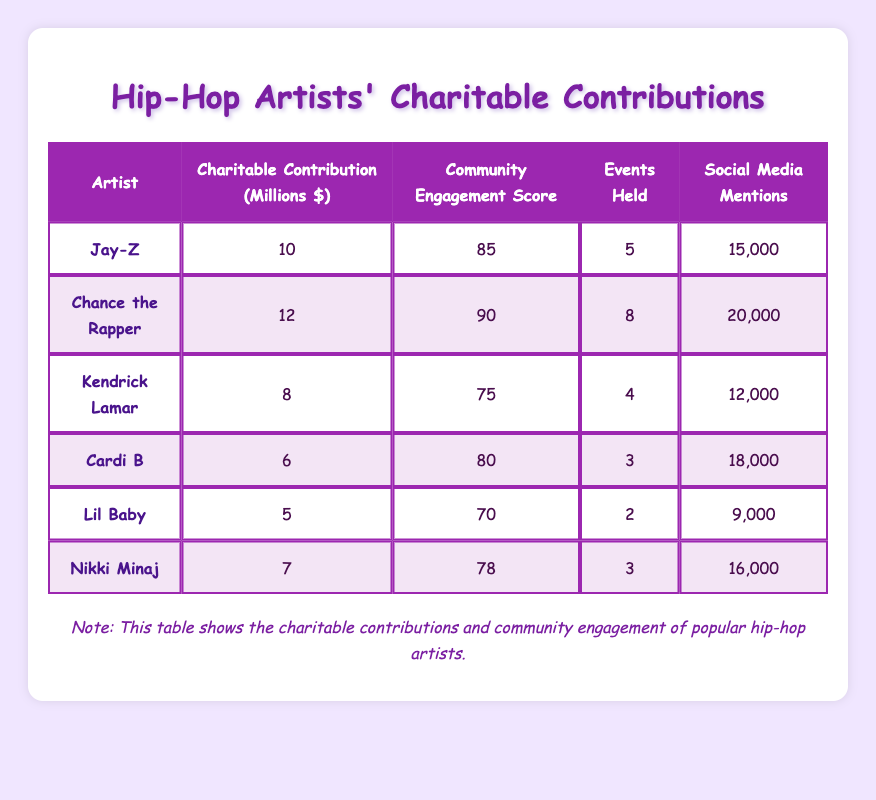What is the community engagement score of Chance the Rapper? The community engagement score for Chance the Rapper is listed in the table under his name. It is 90.
Answer: 90 Who had the highest charitable contributions? By comparing the charitable contributions of each artist listed, Chance the Rapper has the highest contribution at 12 million dollars.
Answer: Chance the Rapper What is the total number of events held by all the artists combined? To find the total events held, we add up the numbers from the "Events Held" column: 5 (Jay-Z) + 8 (Chance the Rapper) + 4 (Kendrick Lamar) + 3 (Cardi B) + 2 (Lil Baby) + 3 (Nikki Minaj) = 25.
Answer: 25 Is Lil Baby's community engagement score lower than Cardi B's? Looking at the community engagement scores, Lil Baby has a score of 70, while Cardi B has a score of 80. Since 70 is less than 80, the answer is yes.
Answer: Yes What is the average charitable contribution among the artists? To find the average, we sum the contributions: 10 + 12 + 8 + 6 + 5 + 7 = 48. There are 6 artists, so we divide the sum by 6: 48 / 6 = 8.
Answer: 8 Which artist had the lowest social media mentions? By examining the "Social Media Mentions" column, we see that Lil Baby has the lowest number at 9,000 mentions.
Answer: Lil Baby Do Cardi B and Kendrick Lamar both have community engagement scores above 75? Checking their scores, Cardi B has 80 and Kendrick Lamar has 75. Kendrick Lamar does not exceed 75, so the answer is no.
Answer: No What is the difference in community engagement scores between Chance the Rapper and Nikki Minaj? Chance the Rapper has a score of 90, and Nikki Minaj has a score of 78. The difference is 90 - 78 = 12.
Answer: 12 What percentage of total social media mentions does Chance the Rapper have compared to the total for all artists? First, we find the total social media mentions: 15,000 + 20,000 + 12,000 + 18,000 + 9,000 + 16,000 = 90,000. Chance the Rapper has 20,000 mentions. The percentage is (20,000 / 90,000) * 100 = 22.22%.
Answer: 22.22% 